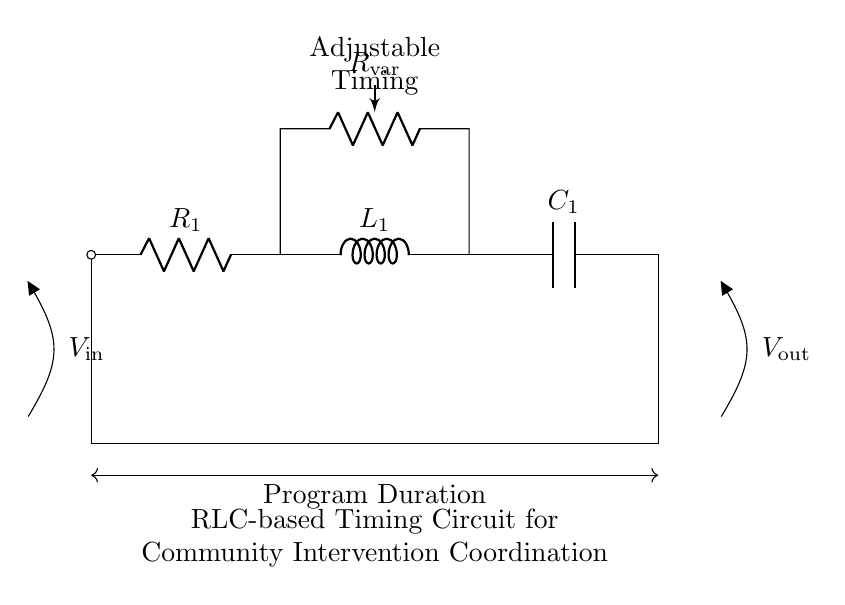What are the components of the circuit? The circuit consists of a resistor, inductor, and capacitor, which are essential elements in RLC circuits. They are shown with their standard symbols in the diagram.
Answer: resistor, inductor, capacitor What is the role of R in this circuit? The resistor, labeled R1 in the circuit, primarily controls the amount of current flow, which affects the timing characteristics of the circuit. Adjustments to the resistor setting can influence the timing interval.
Answer: current control What is the purpose of the adjustable resistor? The adjustable resistor, labeled R_var, allows for fine-tuning of the circuit's timing characteristics without changing the main components, enabling flexibility in programming intervention timelines.
Answer: timing adjustment How does the inductor affect timing? The inductor stores energy in a magnetic field and contributes to the phase shift in the circuit response, which is critical for determining the timing intervals in conjunction with the resistor and capacitor.
Answer: phase shift What happens when the capacitor is fully charged? When the capacitor is fully charged, it reaches its maximum voltage, effectively halting current flow through the circuit, which determines when the intervention actions are executed.
Answer: current halts What is the output of the timing circuit? The output, labeled V_out in the diagram, represents the voltage across the capacitor when the timing circuit completes its cycle, signaling the completion of the intervention program.
Answer: program voltage 